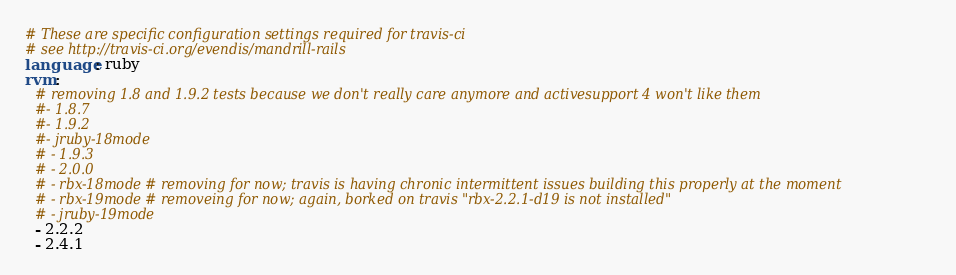<code> <loc_0><loc_0><loc_500><loc_500><_YAML_># These are specific configuration settings required for travis-ci
# see http://travis-ci.org/evendis/mandrill-rails
language: ruby
rvm:
  # removing 1.8 and 1.9.2 tests because we don't really care anymore and activesupport 4 won't like them
  #- 1.8.7
  #- 1.9.2
  #- jruby-18mode
  # - 1.9.3
  # - 2.0.0
  # - rbx-18mode # removing for now; travis is having chronic intermittent issues building this properly at the moment
  # - rbx-19mode # removeing for now; again, borked on travis "rbx-2.2.1-d19 is not installed"
  # - jruby-19mode
  - 2.2.2
  - 2.4.1
</code> 